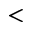Convert formula to latex. <formula><loc_0><loc_0><loc_500><loc_500><</formula> 